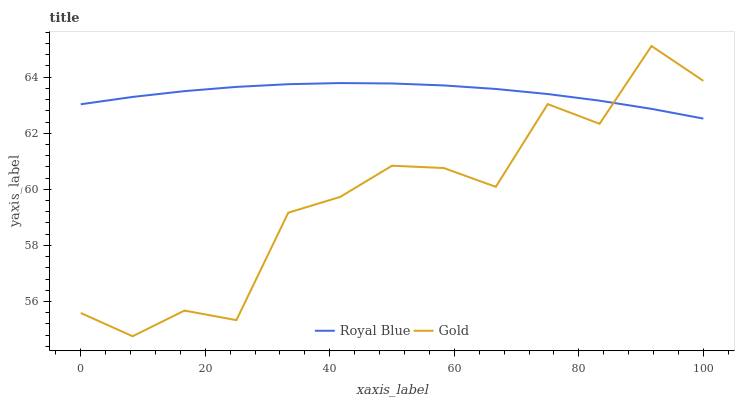Does Gold have the minimum area under the curve?
Answer yes or no. Yes. Does Royal Blue have the maximum area under the curve?
Answer yes or no. Yes. Does Gold have the maximum area under the curve?
Answer yes or no. No. Is Royal Blue the smoothest?
Answer yes or no. Yes. Is Gold the roughest?
Answer yes or no. Yes. Is Gold the smoothest?
Answer yes or no. No. Does Gold have the lowest value?
Answer yes or no. Yes. Does Gold have the highest value?
Answer yes or no. Yes. Does Gold intersect Royal Blue?
Answer yes or no. Yes. Is Gold less than Royal Blue?
Answer yes or no. No. Is Gold greater than Royal Blue?
Answer yes or no. No. 